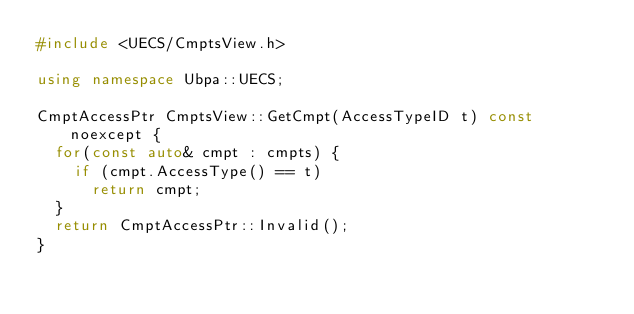Convert code to text. <code><loc_0><loc_0><loc_500><loc_500><_C++_>#include <UECS/CmptsView.h>

using namespace Ubpa::UECS;

CmptAccessPtr CmptsView::GetCmpt(AccessTypeID t) const noexcept {
	for(const auto& cmpt : cmpts) {
		if (cmpt.AccessType() == t)
			return cmpt;
	}
	return CmptAccessPtr::Invalid();
}
</code> 